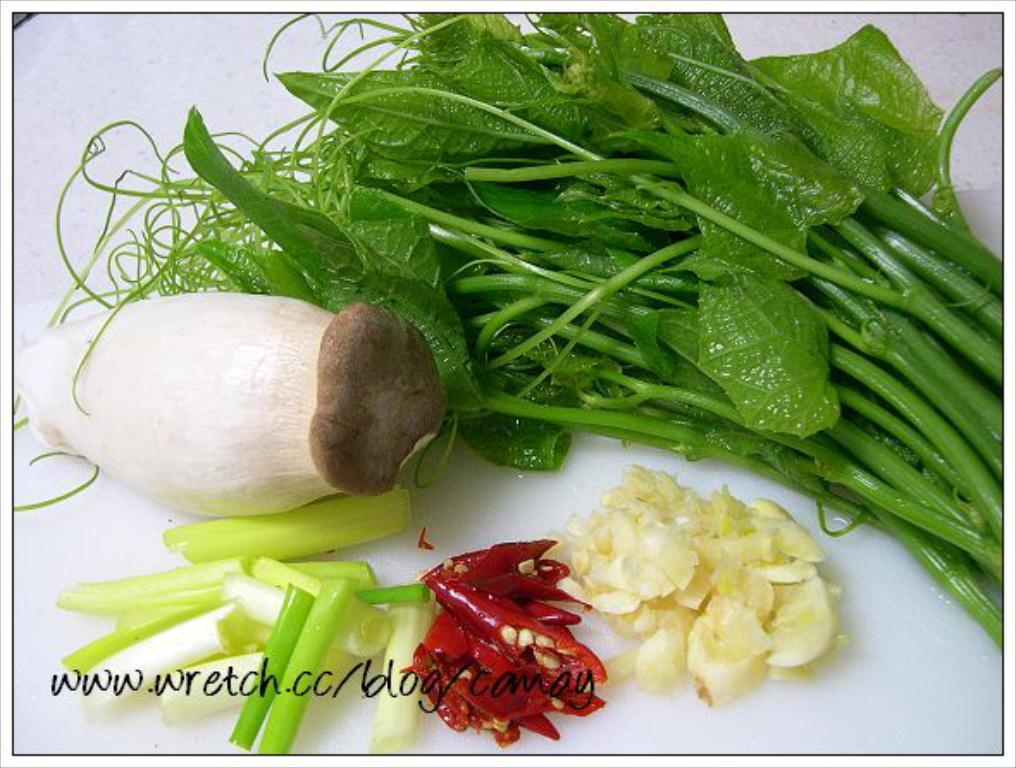What type of vegetable can be seen in the image? There is a mushroom, chopped spring onions, a leafy vegetable, and chopped garlic visible in the image. What other ingredients are present in the image? There are red chilies in the image. Where does the image appear to be displayed? The image appears to be on a whiteboard. Is there any additional marking on the image? Yes, there is a watermark on the image. How many zebras can be seen grazing in the image? There are no zebras present in the image; it features vegetables and ingredients on a whiteboard. What type of cheese is being used in the image? There is no cheese present in the image. 